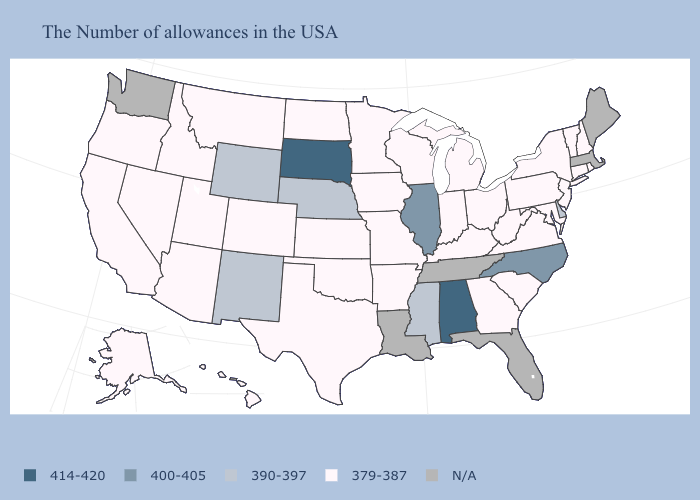What is the value of Maine?
Be succinct. N/A. Does South Dakota have the lowest value in the USA?
Be succinct. No. What is the value of Kentucky?
Answer briefly. 379-387. Name the states that have a value in the range 390-397?
Answer briefly. Delaware, Mississippi, Nebraska, Wyoming, New Mexico. What is the value of Wisconsin?
Be succinct. 379-387. Is the legend a continuous bar?
Be succinct. No. Is the legend a continuous bar?
Write a very short answer. No. Does Ohio have the highest value in the MidWest?
Short answer required. No. Does Indiana have the highest value in the USA?
Write a very short answer. No. What is the highest value in states that border Georgia?
Answer briefly. 414-420. What is the highest value in the South ?
Give a very brief answer. 414-420. Among the states that border Texas , which have the lowest value?
Be succinct. Arkansas, Oklahoma. Among the states that border Wyoming , does Idaho have the highest value?
Short answer required. No. 